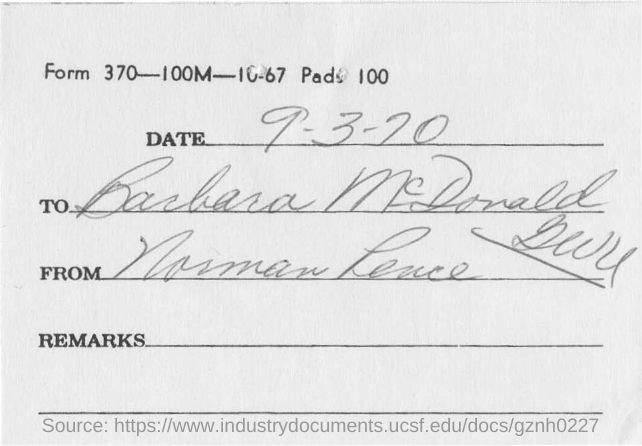Mention a couple of crucial points in this snapshot. The document is addressed to Barbara McDonald. The date mentioned in the document is September 3, 1970. 